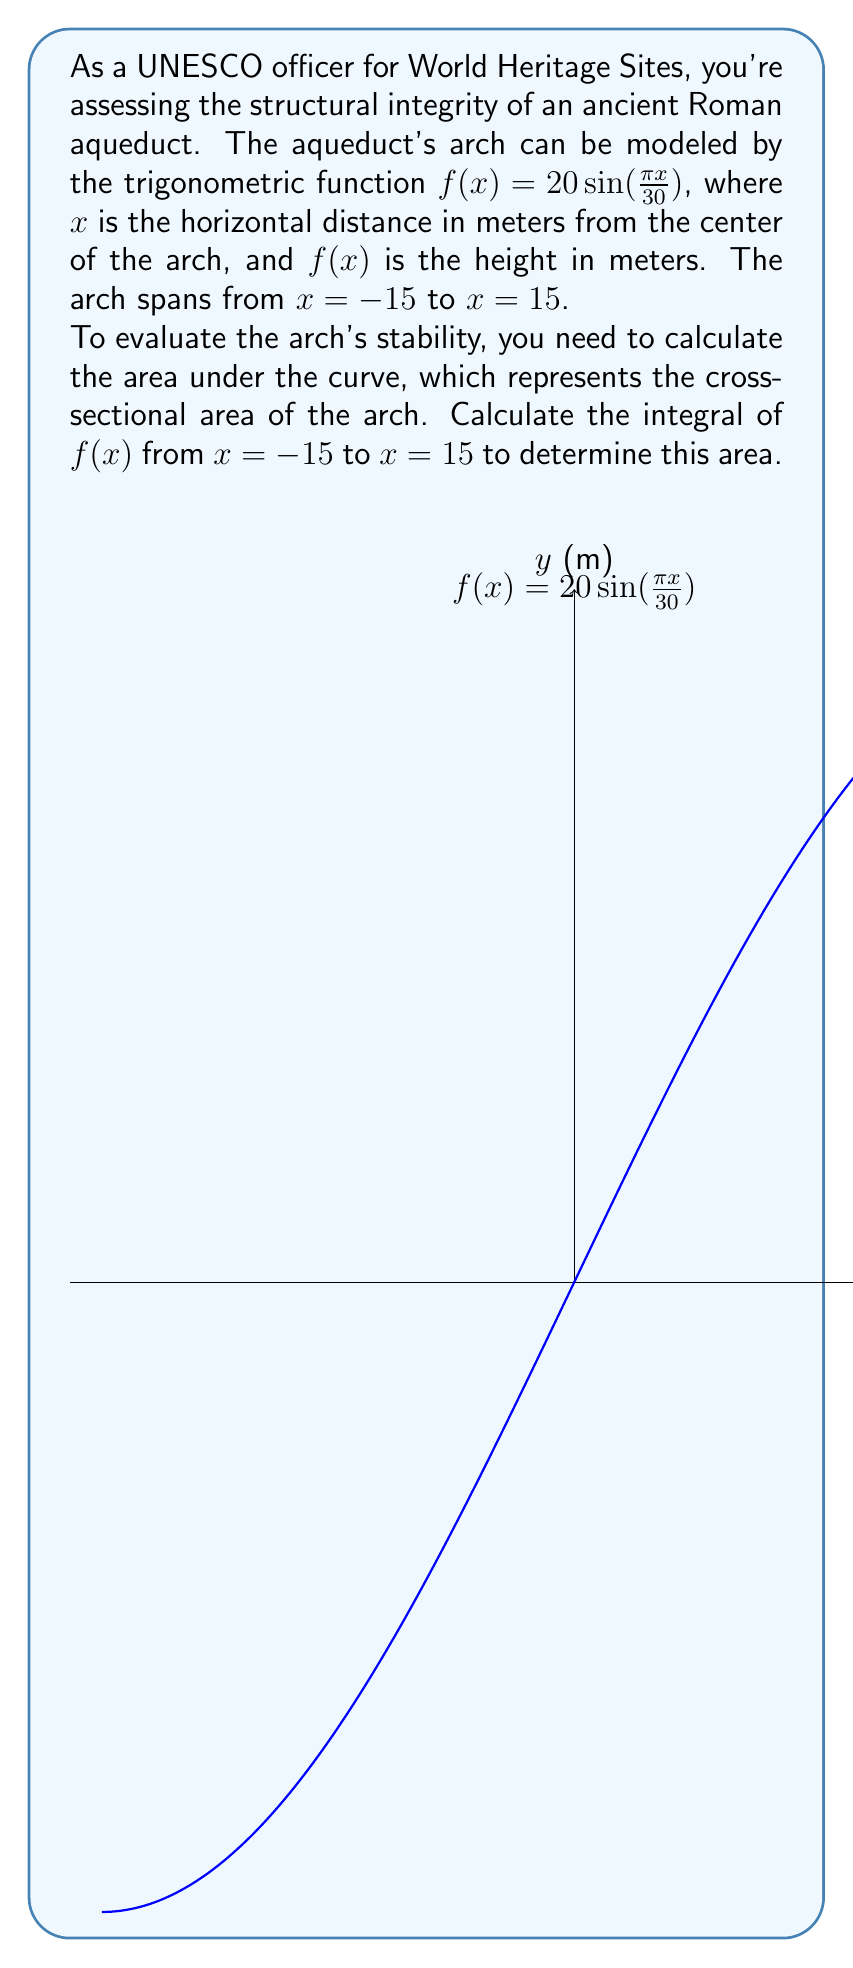Provide a solution to this math problem. To solve this problem, we need to integrate the function $f(x) = 20 \sin(\frac{\pi x}{30})$ from $x = -15$ to $x = 15$. Let's break it down step-by-step:

1) The integral we need to calculate is:

   $$\int_{-15}^{15} 20 \sin(\frac{\pi x}{30}) dx$$

2) To integrate this, we can use the substitution method. Let $u = \frac{\pi x}{30}$. Then:

   $du = \frac{\pi}{30} dx$
   $dx = \frac{30}{\pi} du$

3) When $x = -15$, $u = -\frac{\pi}{2}$
   When $x = 15$, $u = \frac{\pi}{2}$

4) Substituting these into our integral:

   $$\int_{-\frac{\pi}{2}}^{\frac{\pi}{2}} 20 \sin(u) \cdot \frac{30}{\pi} du = \frac{600}{\pi} \int_{-\frac{\pi}{2}}^{\frac{\pi}{2}} \sin(u) du$$

5) The integral of sine from $-\frac{\pi}{2}$ to $\frac{\pi}{2}$ is:

   $$[-\cos(u)]_{-\frac{\pi}{2}}^{\frac{\pi}{2}} = -\cos(\frac{\pi}{2}) - (-\cos(-\frac{\pi}{2})) = -0 - (-0) = 0$$

6) Therefore, our final result is:

   $$\frac{600}{\pi} \cdot 2 = \frac{1200}{\pi}$$

This value represents the area under the curve in square meters, which is the cross-sectional area of the aqueduct's arch.
Answer: $\frac{1200}{\pi}$ square meters 